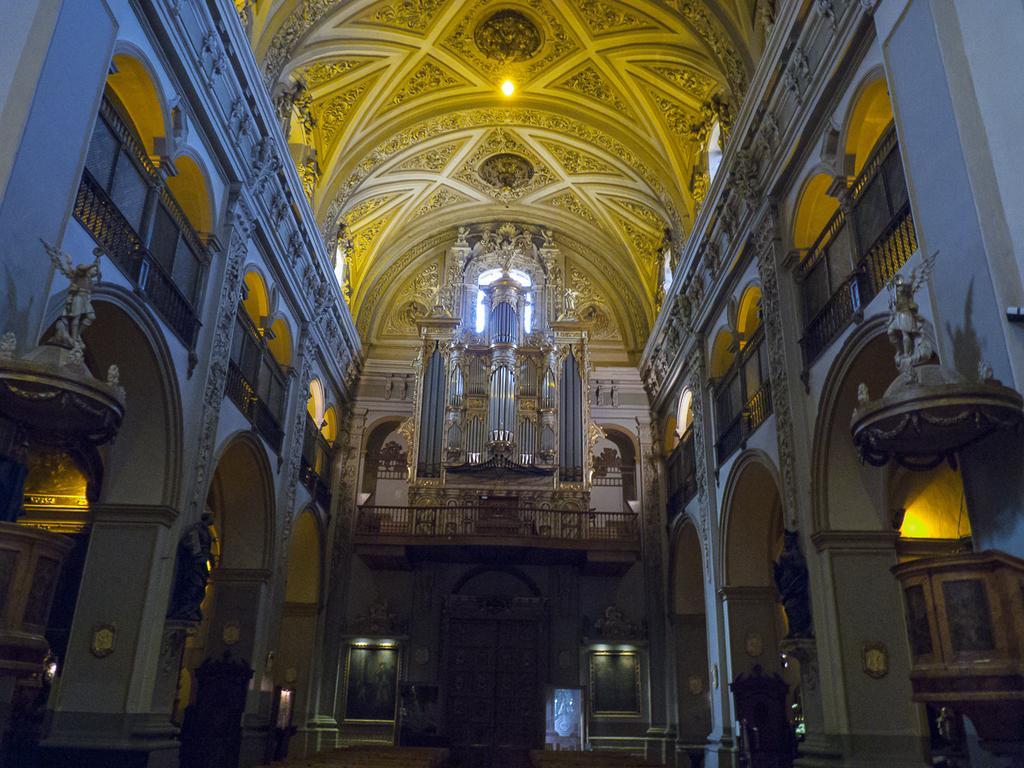How would you summarize this image in a sentence or two? In this image we can see the inside view of parish building which has some sculptures, doors, lights and chandeliers. 